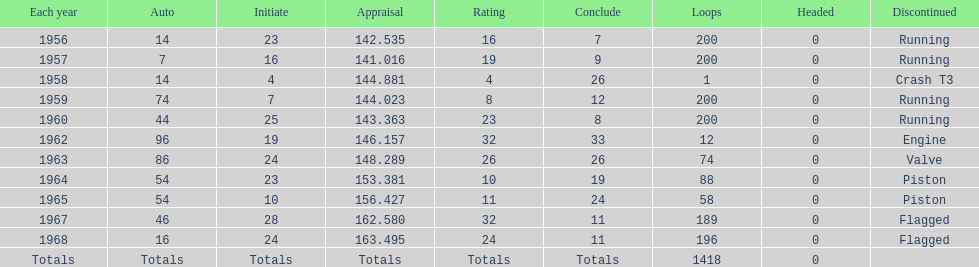How long did bob veith have the number 54 car at the indy 500? 2 years. 